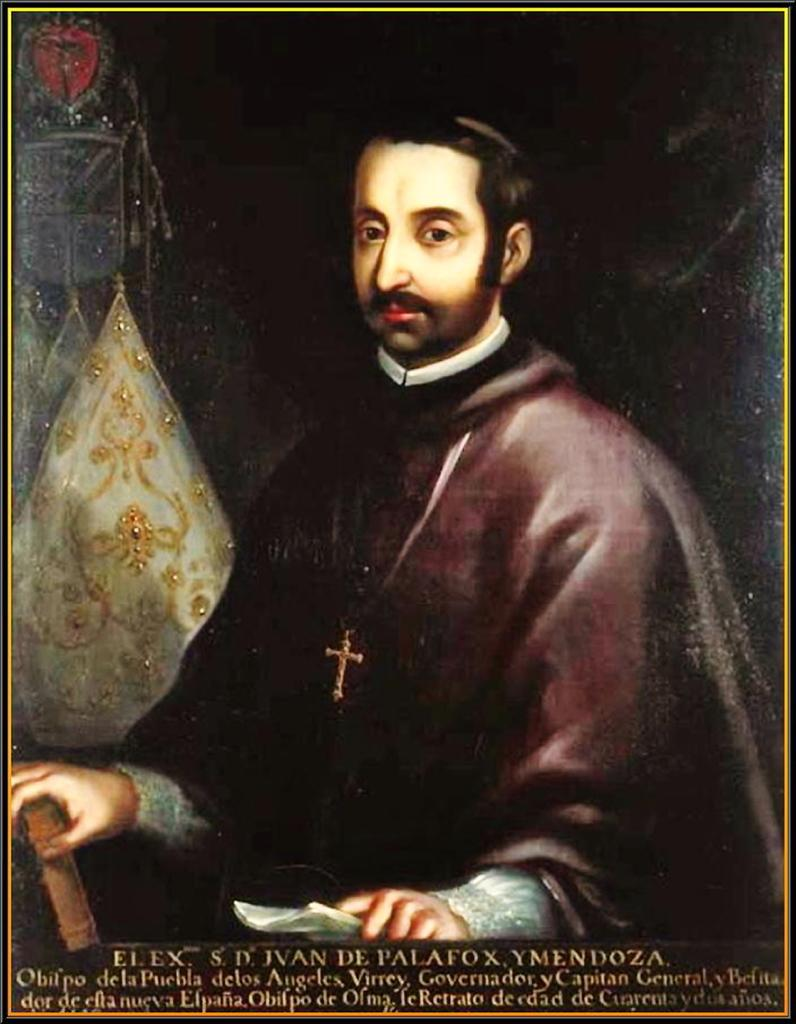What is the main subject of the image? There is a person depicted in the image. Can you describe anything in the background of the image? There is an object in the background of the image. What is located at the bottom of the image? Text is present at the bottom of the image. How is the image framed? The image has borders. How often does the person wash their clothes in the image? There is no information about the person washing clothes in the image. 